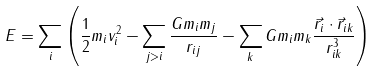<formula> <loc_0><loc_0><loc_500><loc_500>E = \sum _ { i } \left ( \frac { 1 } { 2 } m _ { i } v _ { i } ^ { 2 } - \sum _ { j > i } \frac { G m _ { i } m _ { j } } { r _ { i j } } - \sum _ { k } G m _ { i } m _ { k } \frac { \vec { r } _ { i } \cdot \vec { r } _ { i k } } { r _ { i k } ^ { 3 } } \right )</formula> 